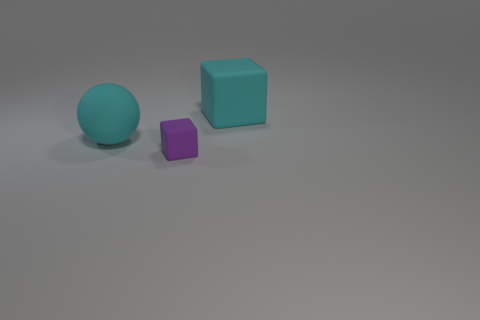Subtract all purple blocks. How many blocks are left? 1 Add 1 green matte objects. How many objects exist? 4 Subtract all spheres. How many objects are left? 2 Subtract 2 blocks. How many blocks are left? 0 Subtract all green blocks. Subtract all red spheres. How many blocks are left? 2 Subtract all red spheres. How many purple blocks are left? 1 Subtract all big green objects. Subtract all large cyan matte things. How many objects are left? 1 Add 3 cyan balls. How many cyan balls are left? 4 Add 2 cyan cylinders. How many cyan cylinders exist? 2 Subtract 0 blue cylinders. How many objects are left? 3 